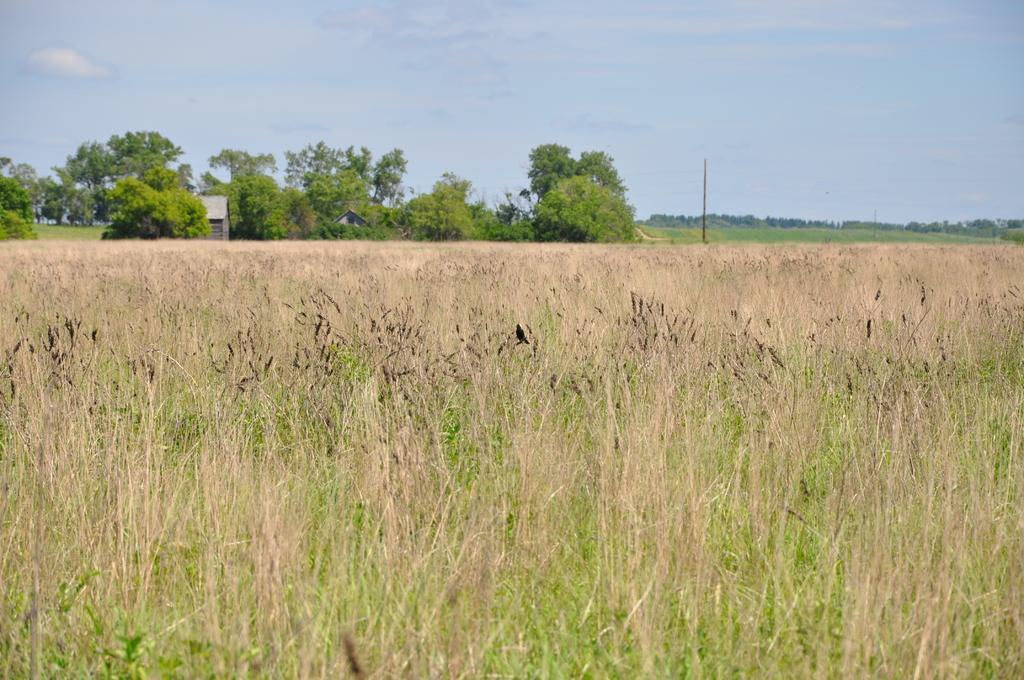Please provide a concise description of this image. In This image in the foreground there are some plants and in the background there are trees, house, pole and at the top of the image there is sky. 